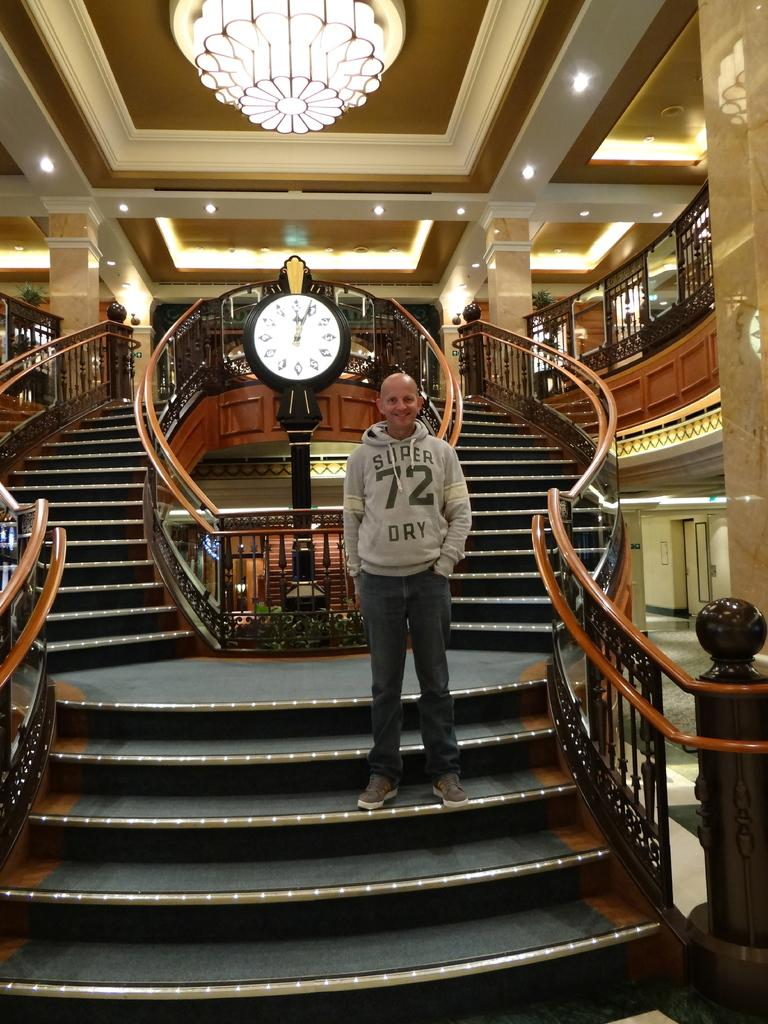<image>
Share a concise interpretation of the image provided. A man in a sweatshirt with the number 72 on it stands on a staircase. 